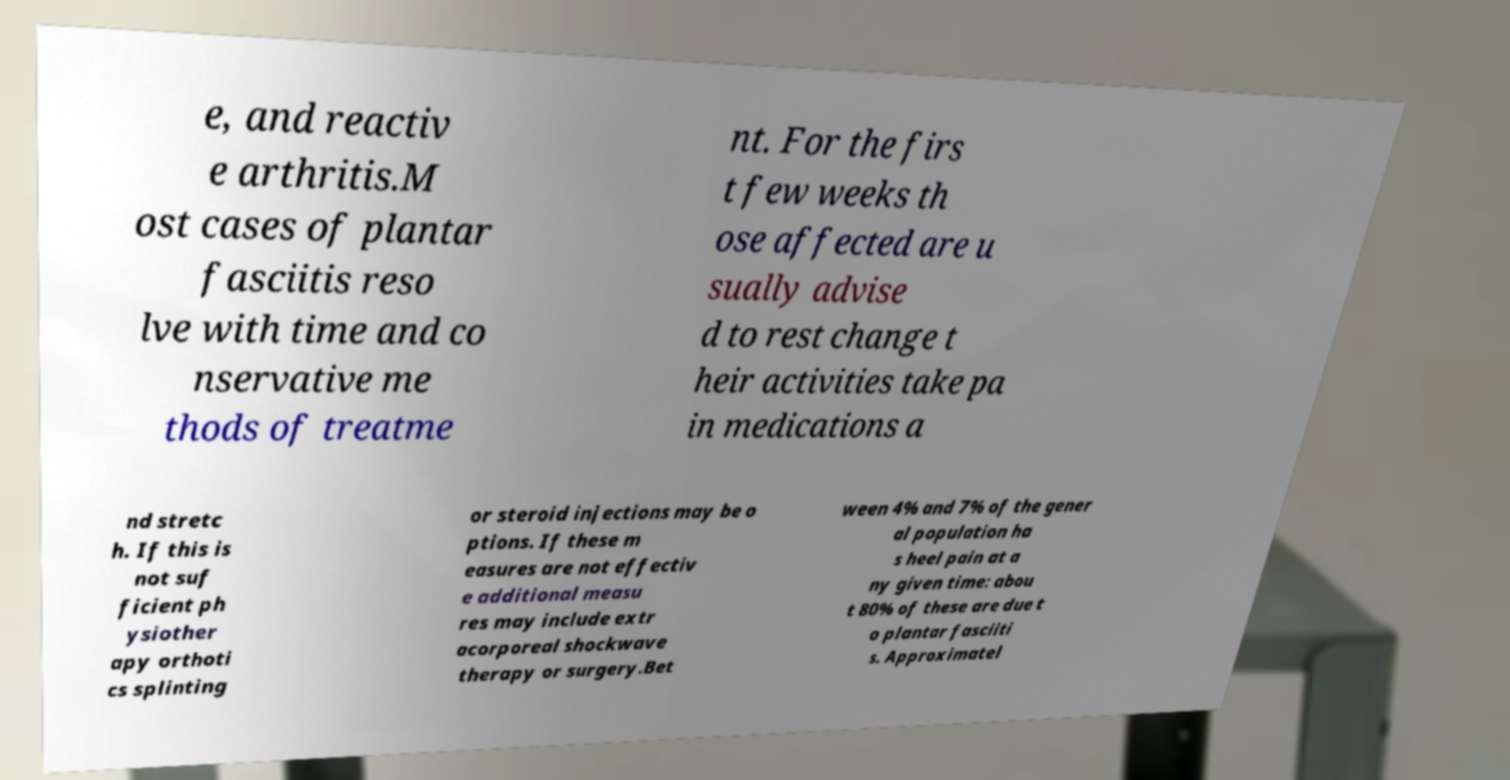Can you read and provide the text displayed in the image?This photo seems to have some interesting text. Can you extract and type it out for me? e, and reactiv e arthritis.M ost cases of plantar fasciitis reso lve with time and co nservative me thods of treatme nt. For the firs t few weeks th ose affected are u sually advise d to rest change t heir activities take pa in medications a nd stretc h. If this is not suf ficient ph ysiother apy orthoti cs splinting or steroid injections may be o ptions. If these m easures are not effectiv e additional measu res may include extr acorporeal shockwave therapy or surgery.Bet ween 4% and 7% of the gener al population ha s heel pain at a ny given time: abou t 80% of these are due t o plantar fasciiti s. Approximatel 